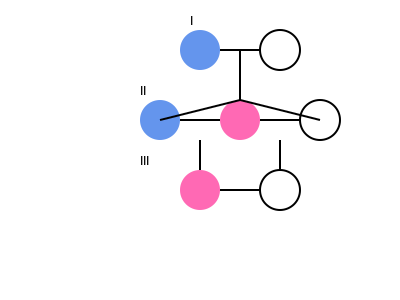Analyze the pedigree chart above representing the inheritance of albinism in a family. Given that albinism is an autosomal recessive disorder, what is the probability that the next child of the couple in generation III will have albinism? To solve this problem, we need to follow these steps:

1. Identify the genotypes of the parents in generation III:
   - The affected male must have two recessive alleles (aa)
   - The unaffected female must have at least one dominant allele (A)

2. Determine the possible genotype of the unaffected female:
   - She must be a carrier (Aa) because:
     a) Her father is affected (aa)
     b) She has an affected brother (aa)

3. List the possible gametes from each parent:
   - Affected male (aa): 100% a
   - Carrier female (Aa): 50% A, 50% a

4. Calculate the probability of an affected child:
   - Probability of receiving 'a' from the father = 1
   - Probability of receiving 'a' from the mother = 1/2
   - Probability of both events occurring = 1 × 1/2 = 1/2

Therefore, the probability of their next child having albinism is 1/2 or 50%.
Answer: 1/2 or 50% 